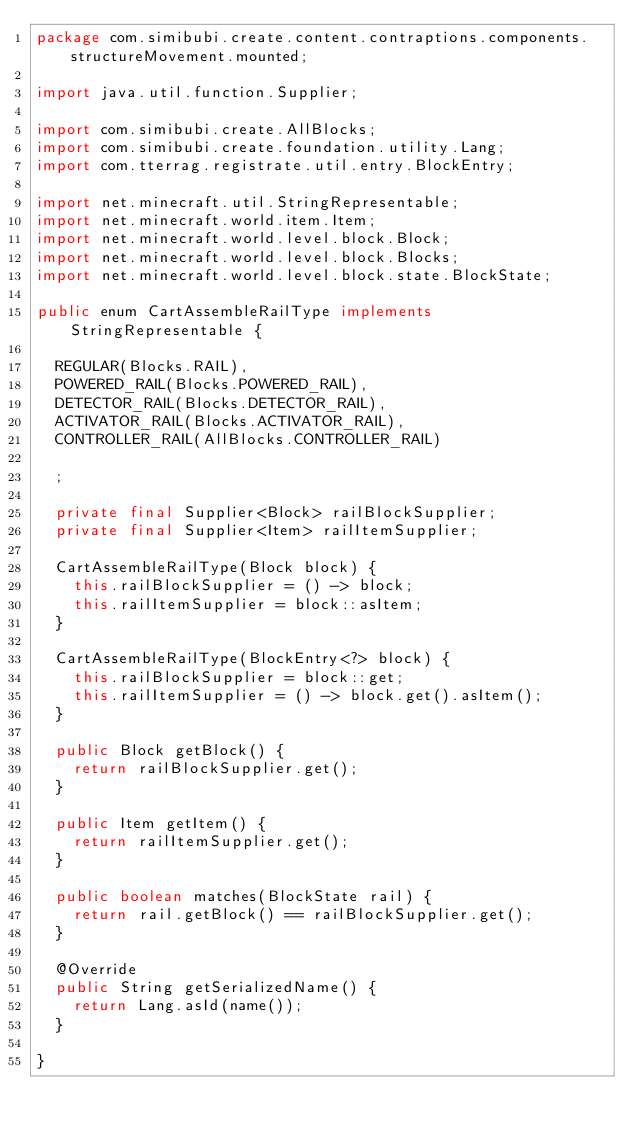<code> <loc_0><loc_0><loc_500><loc_500><_Java_>package com.simibubi.create.content.contraptions.components.structureMovement.mounted;

import java.util.function.Supplier;

import com.simibubi.create.AllBlocks;
import com.simibubi.create.foundation.utility.Lang;
import com.tterrag.registrate.util.entry.BlockEntry;

import net.minecraft.util.StringRepresentable;
import net.minecraft.world.item.Item;
import net.minecraft.world.level.block.Block;
import net.minecraft.world.level.block.Blocks;
import net.minecraft.world.level.block.state.BlockState;

public enum CartAssembleRailType implements StringRepresentable {
	
	REGULAR(Blocks.RAIL),
	POWERED_RAIL(Blocks.POWERED_RAIL),
	DETECTOR_RAIL(Blocks.DETECTOR_RAIL),
	ACTIVATOR_RAIL(Blocks.ACTIVATOR_RAIL),
	CONTROLLER_RAIL(AllBlocks.CONTROLLER_RAIL)
	
	;

	private final Supplier<Block> railBlockSupplier;
	private final Supplier<Item> railItemSupplier;

	CartAssembleRailType(Block block) {
		this.railBlockSupplier = () -> block;
		this.railItemSupplier = block::asItem;
	}

	CartAssembleRailType(BlockEntry<?> block) {
		this.railBlockSupplier = block::get;
		this.railItemSupplier = () -> block.get().asItem();
	}

	public Block getBlock() {
		return railBlockSupplier.get();
	}

	public Item getItem() {
		return railItemSupplier.get();
	}
	
	public boolean matches(BlockState rail) {
		return rail.getBlock() == railBlockSupplier.get();
	}
	
	@Override
	public String getSerializedName() {
		return Lang.asId(name());
	}

}
</code> 